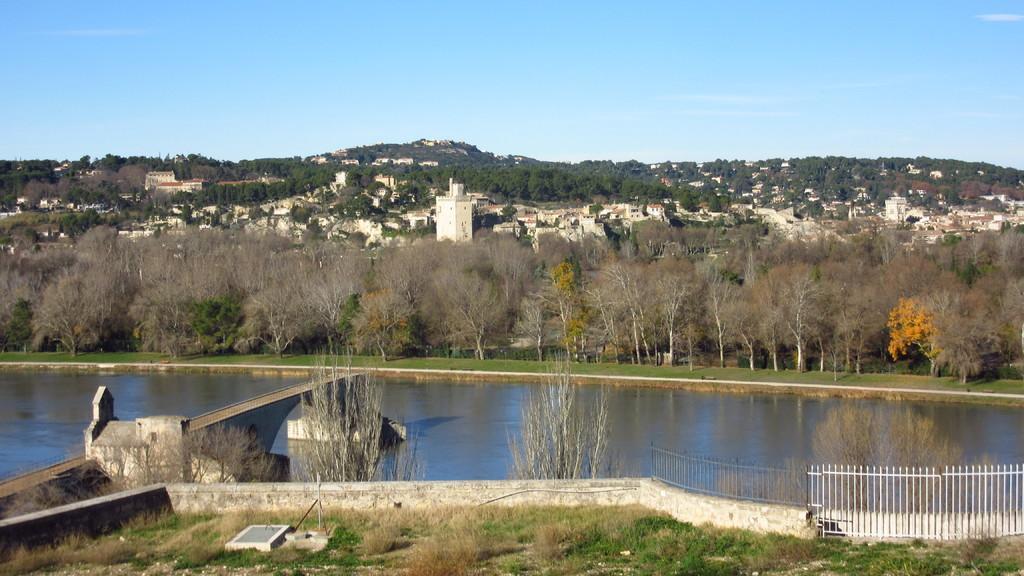Could you give a brief overview of what you see in this image? In this picture I can observe lake in the middle of the picture. On the right side I can observe railing. In the background there are trees and sky. 